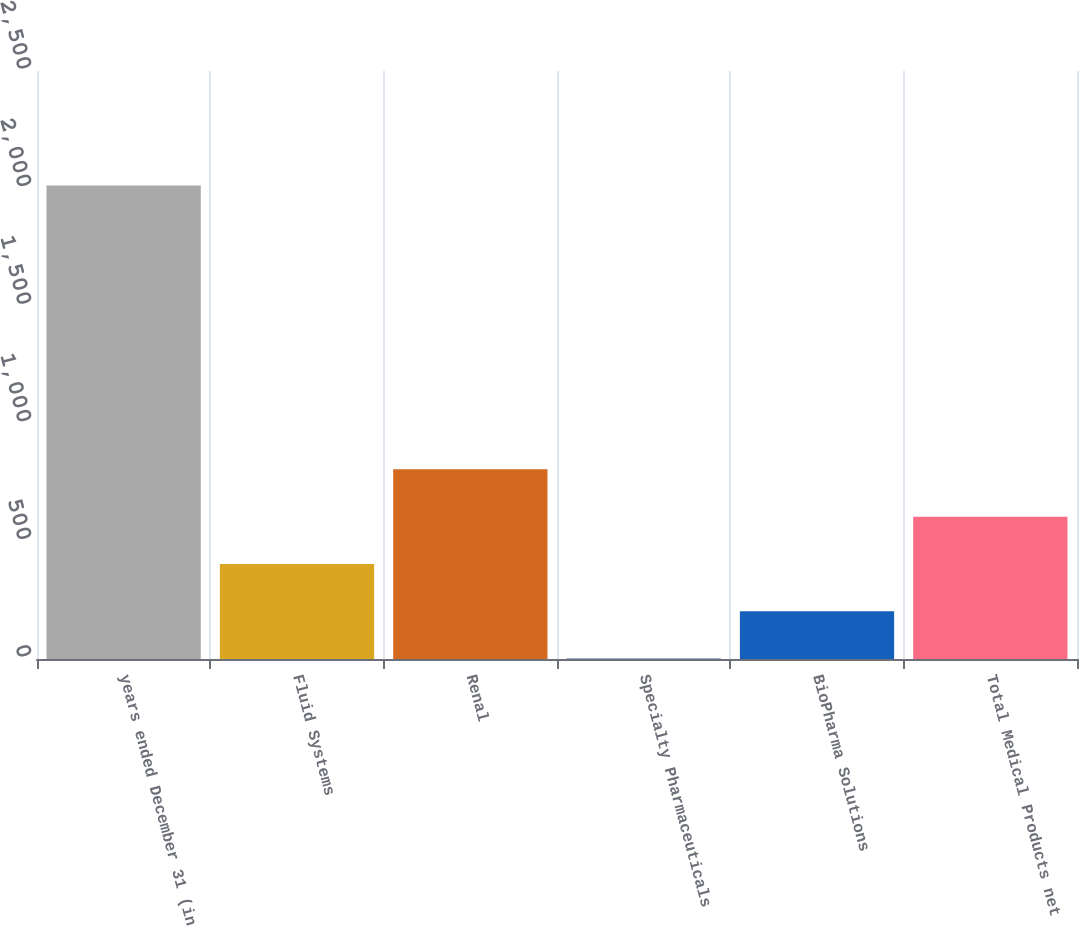Convert chart. <chart><loc_0><loc_0><loc_500><loc_500><bar_chart><fcel>years ended December 31 (in<fcel>Fluid Systems<fcel>Renal<fcel>Specialty Pharmaceuticals<fcel>BioPharma Solutions<fcel>Total Medical Products net<nl><fcel>2013<fcel>404.2<fcel>806.4<fcel>2<fcel>203.1<fcel>605.3<nl></chart> 